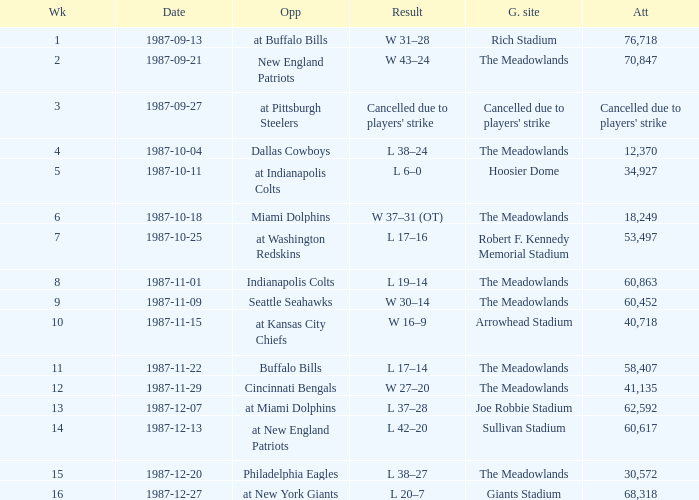Who did the Jets play in their post-week 15 game? At new york giants. 